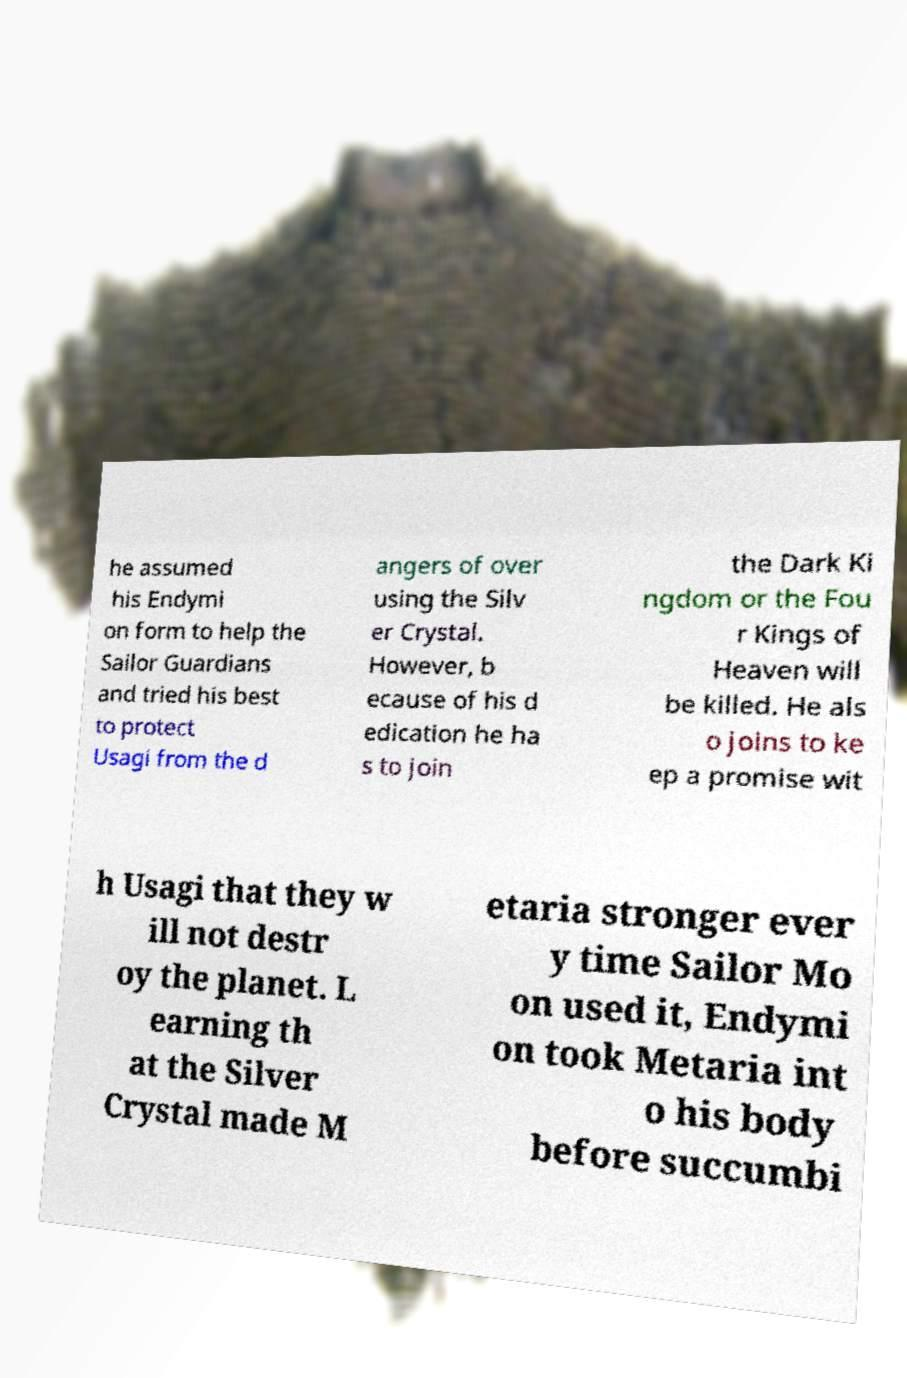For documentation purposes, I need the text within this image transcribed. Could you provide that? he assumed his Endymi on form to help the Sailor Guardians and tried his best to protect Usagi from the d angers of over using the Silv er Crystal. However, b ecause of his d edication he ha s to join the Dark Ki ngdom or the Fou r Kings of Heaven will be killed. He als o joins to ke ep a promise wit h Usagi that they w ill not destr oy the planet. L earning th at the Silver Crystal made M etaria stronger ever y time Sailor Mo on used it, Endymi on took Metaria int o his body before succumbi 